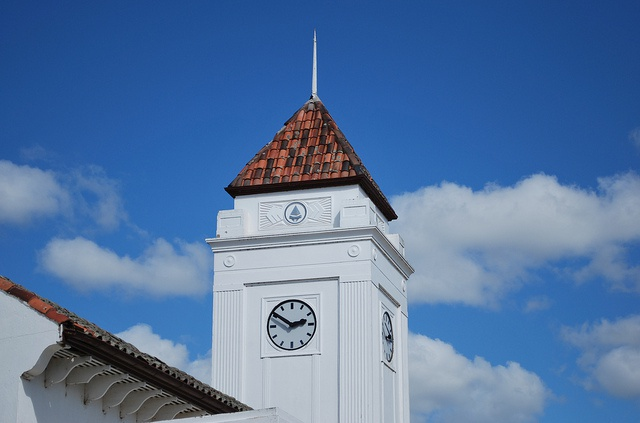Describe the objects in this image and their specific colors. I can see clock in darkblue, darkgray, black, and gray tones and clock in darkblue, darkgray, gray, and black tones in this image. 